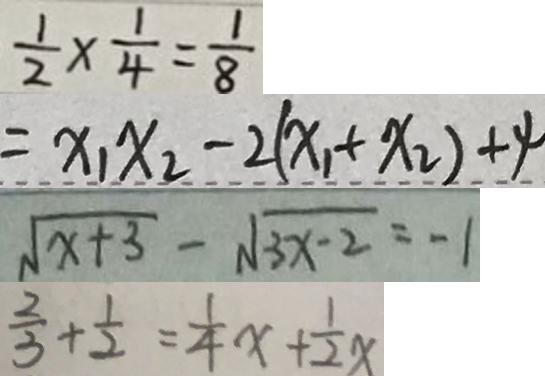<formula> <loc_0><loc_0><loc_500><loc_500>\frac { 1 } { 2 } \times \frac { 1 } { 4 } = \frac { 1 } { 8 } 
 = x _ { 1 } x _ { 2 } - 2 ( x _ { 1 } + x _ { 2 } ) + 4 
 \sqrt { x + 3 } - \sqrt { 3 x - 2 } = - 1 
 \frac { 2 } { 3 } + \frac { 1 } { 2 } = \frac { 1 } { 4 } x + \frac { 1 } { 2 } x</formula> 